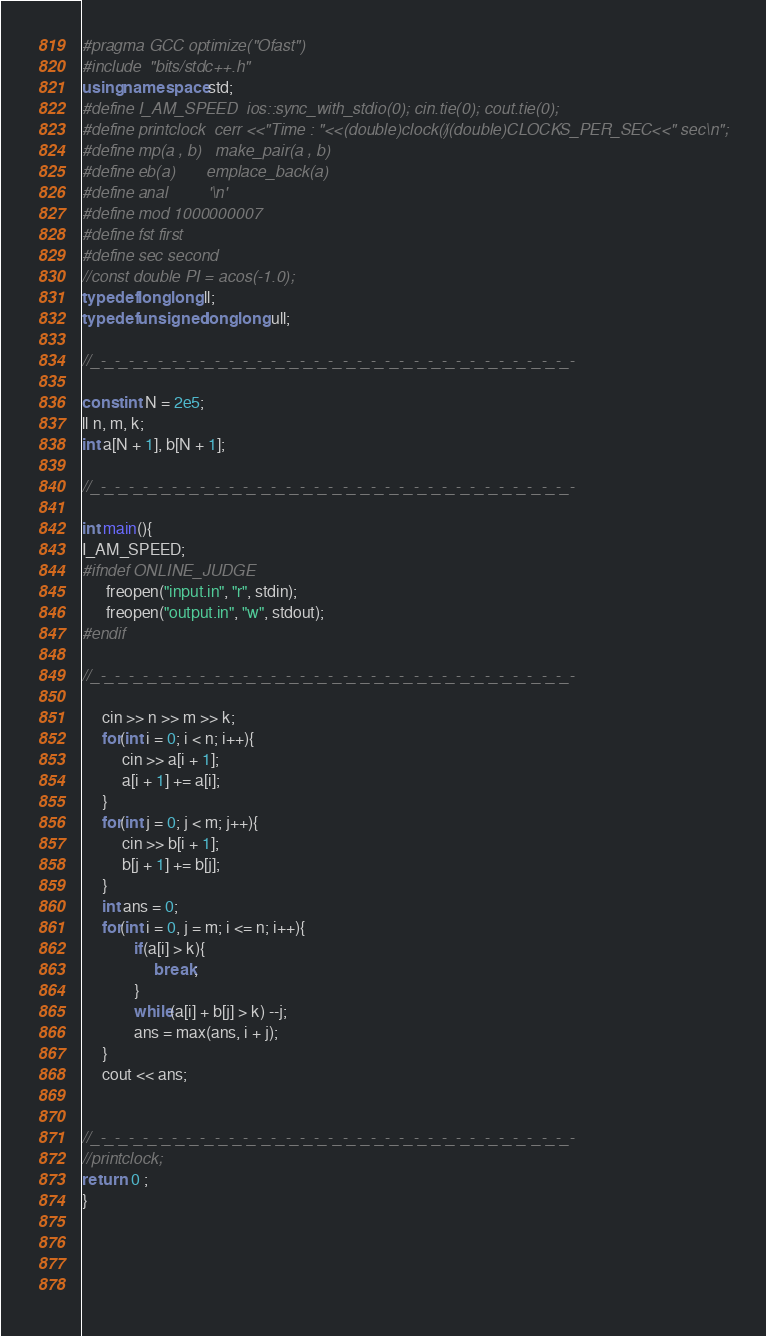<code> <loc_0><loc_0><loc_500><loc_500><_C++_>#pragma GCC optimize("Ofast")
#include  "bits/stdc++.h"
using namespace std;
#define I_AM_SPEED  ios::sync_with_stdio(0); cin.tie(0); cout.tie(0); 
#define printclock  cerr <<"Time : "<<(double)clock()/(double)CLOCKS_PER_SEC<<" sec\n";
#define mp(a , b)   make_pair(a , b)
#define eb(a)       emplace_back(a)
#define anal         '\n'
#define mod 1000000007
#define fst first
#define sec second
//const double PI = acos(-1.0);
typedef long long ll;
typedef unsigned long long ull;

//_-_-_-_-_-_-_-_-_-_-_-_-_-_-_-_-_-_-_-_-_-_-_-_-_-_-_-_-_-_-_-_-_-_-

const int N = 2e5;
ll n, m, k;
int a[N + 1], b[N + 1];

//_-_-_-_-_-_-_-_-_-_-_-_-_-_-_-_-_-_-_-_-_-_-_-_-_-_-_-_-_-_-_-_-_-_-
      
int main(){
I_AM_SPEED;
#ifndef ONLINE_JUDGE  
      freopen("input.in", "r", stdin);
      freopen("output.in", "w", stdout);
#endif 

//_-_-_-_-_-_-_-_-_-_-_-_-_-_-_-_-_-_-_-_-_-_-_-_-_-_-_-_-_-_-_-_-_-_-
     
     cin >> n >> m >> k;
     for(int i = 0; i < n; i++){
          cin >> a[i + 1];
          a[i + 1] += a[i];
     } 
     for(int j = 0; j < m; j++){
          cin >> b[i + 1];
          b[j + 1] += b[j];
     }
     int ans = 0;
     for(int i = 0, j = m; i <= n; i++){
             if(a[i] > k){
                  break;
             }
             while(a[i] + b[j] > k) --j;
             ans = max(ans, i + j);
     }
     cout << ans;


//_-_-_-_-_-_-_-_-_-_-_-_-_-_-_-_-_-_-_-_-_-_-_-_-_-_-_-_-_-_-_-_-_-_-
//printclock; 
return  0 ;      
}        



   </code> 